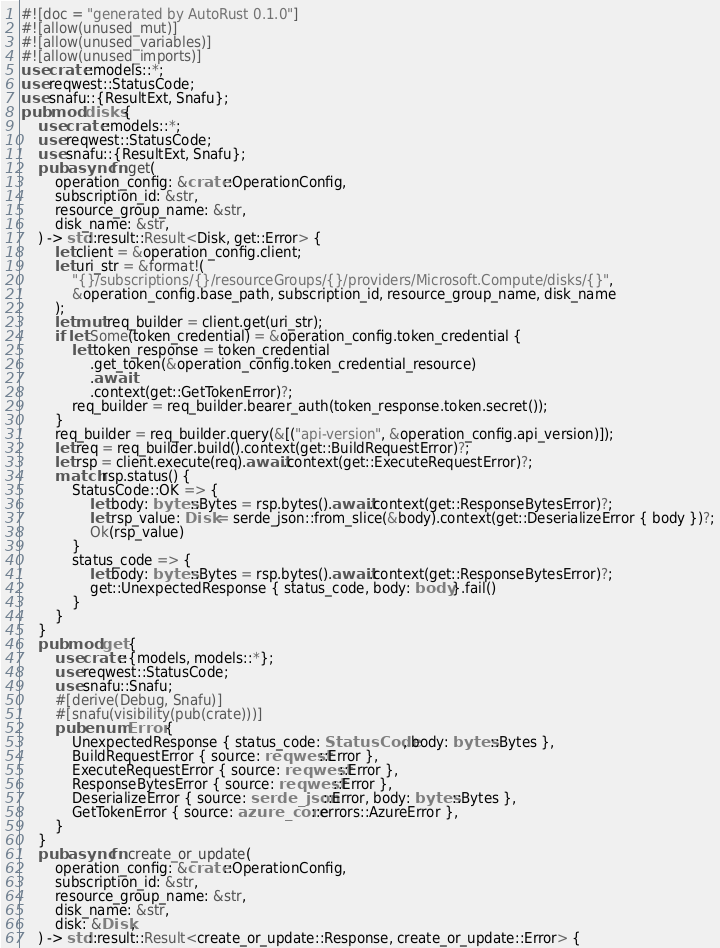Convert code to text. <code><loc_0><loc_0><loc_500><loc_500><_Rust_>#![doc = "generated by AutoRust 0.1.0"]
#![allow(unused_mut)]
#![allow(unused_variables)]
#![allow(unused_imports)]
use crate::models::*;
use reqwest::StatusCode;
use snafu::{ResultExt, Snafu};
pub mod disks {
    use crate::models::*;
    use reqwest::StatusCode;
    use snafu::{ResultExt, Snafu};
    pub async fn get(
        operation_config: &crate::OperationConfig,
        subscription_id: &str,
        resource_group_name: &str,
        disk_name: &str,
    ) -> std::result::Result<Disk, get::Error> {
        let client = &operation_config.client;
        let uri_str = &format!(
            "{}/subscriptions/{}/resourceGroups/{}/providers/Microsoft.Compute/disks/{}",
            &operation_config.base_path, subscription_id, resource_group_name, disk_name
        );
        let mut req_builder = client.get(uri_str);
        if let Some(token_credential) = &operation_config.token_credential {
            let token_response = token_credential
                .get_token(&operation_config.token_credential_resource)
                .await
                .context(get::GetTokenError)?;
            req_builder = req_builder.bearer_auth(token_response.token.secret());
        }
        req_builder = req_builder.query(&[("api-version", &operation_config.api_version)]);
        let req = req_builder.build().context(get::BuildRequestError)?;
        let rsp = client.execute(req).await.context(get::ExecuteRequestError)?;
        match rsp.status() {
            StatusCode::OK => {
                let body: bytes::Bytes = rsp.bytes().await.context(get::ResponseBytesError)?;
                let rsp_value: Disk = serde_json::from_slice(&body).context(get::DeserializeError { body })?;
                Ok(rsp_value)
            }
            status_code => {
                let body: bytes::Bytes = rsp.bytes().await.context(get::ResponseBytesError)?;
                get::UnexpectedResponse { status_code, body: body }.fail()
            }
        }
    }
    pub mod get {
        use crate::{models, models::*};
        use reqwest::StatusCode;
        use snafu::Snafu;
        #[derive(Debug, Snafu)]
        #[snafu(visibility(pub(crate)))]
        pub enum Error {
            UnexpectedResponse { status_code: StatusCode, body: bytes::Bytes },
            BuildRequestError { source: reqwest::Error },
            ExecuteRequestError { source: reqwest::Error },
            ResponseBytesError { source: reqwest::Error },
            DeserializeError { source: serde_json::Error, body: bytes::Bytes },
            GetTokenError { source: azure_core::errors::AzureError },
        }
    }
    pub async fn create_or_update(
        operation_config: &crate::OperationConfig,
        subscription_id: &str,
        resource_group_name: &str,
        disk_name: &str,
        disk: &Disk,
    ) -> std::result::Result<create_or_update::Response, create_or_update::Error> {</code> 